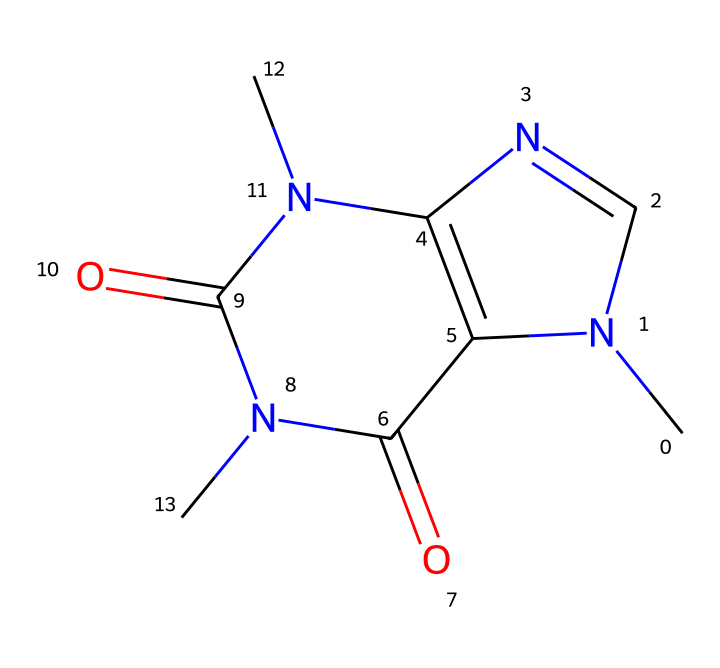What is the chemical name of this structure? The given SMILES notation corresponds to caffeine, commonly known as 1,3,7-trimethylxanthine. This is derived from the structure which contains xanthine, modified by the addition of three methyl groups (from the nitrogen atoms).
Answer: caffeine How many nitrogen atoms are present in this structure? Analyzing the SMILES representation, we can identify four nitrogen atoms (N). Each nitrogen atom is denoted by 'N' in the SMILES, giving the total count.
Answer: four What type of functional groups are present in caffeine? Caffeine contains amine (-NH) groups and carbonyl (C=O) groups. The nitrogen atoms indicate the presence of amines, and the oxygen double-bonds indicate carbonyls.
Answer: amine and carbonyl What is the total number of rings in this chemical structure? The structure of caffeine contains two fused rings as evident from the cyclic configurations within the SMILES, confirming there are two rings overall.
Answer: two Which property is primarily responsible for caffeine's stimulatory effect? The presence of nitrogen atoms allows for the interaction with adenosine receptors in the brain, thus leading to the stimulant effects associated with caffeine consumption.
Answer: nitrogen atoms What type of molecule is caffeine classified as? Caffeine is classified as an alkaloid due to its nitrogen-rich structure and psychoactive effects, which are characteristic of alkaloids.
Answer: alkaloid 